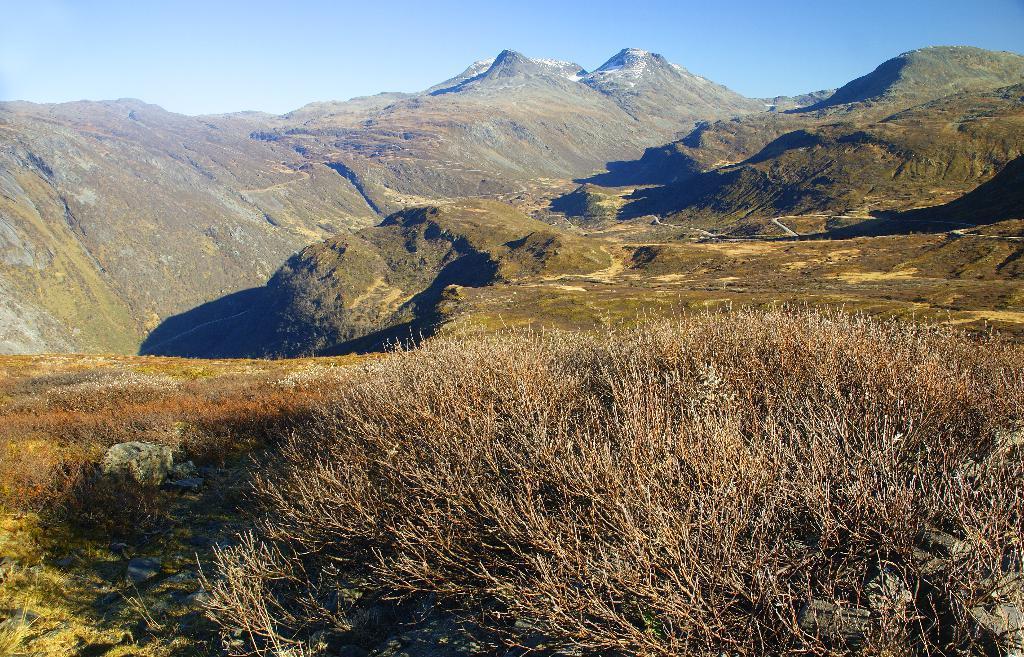Could you give a brief overview of what you see in this image? In the image I can see a place where we have some mountains and also I can see some plants. 